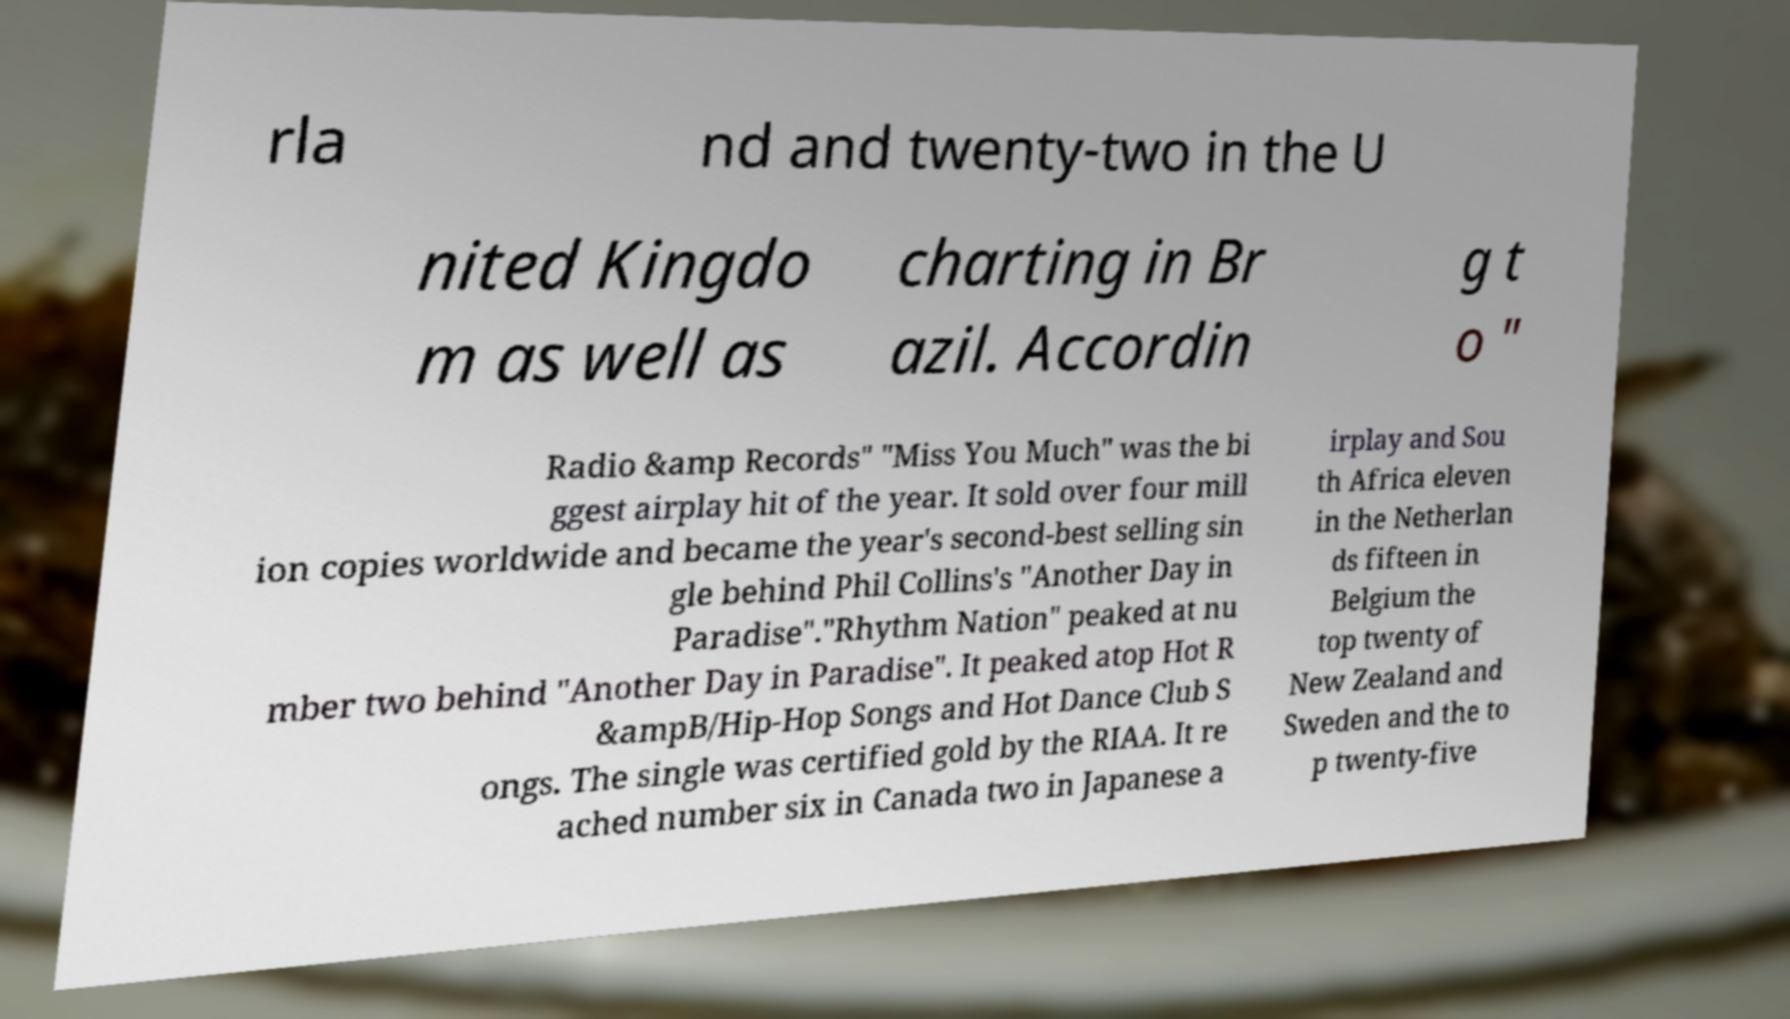There's text embedded in this image that I need extracted. Can you transcribe it verbatim? rla nd and twenty-two in the U nited Kingdo m as well as charting in Br azil. Accordin g t o " Radio &amp Records" "Miss You Much" was the bi ggest airplay hit of the year. It sold over four mill ion copies worldwide and became the year's second-best selling sin gle behind Phil Collins's "Another Day in Paradise"."Rhythm Nation" peaked at nu mber two behind "Another Day in Paradise". It peaked atop Hot R &ampB/Hip-Hop Songs and Hot Dance Club S ongs. The single was certified gold by the RIAA. It re ached number six in Canada two in Japanese a irplay and Sou th Africa eleven in the Netherlan ds fifteen in Belgium the top twenty of New Zealand and Sweden and the to p twenty-five 